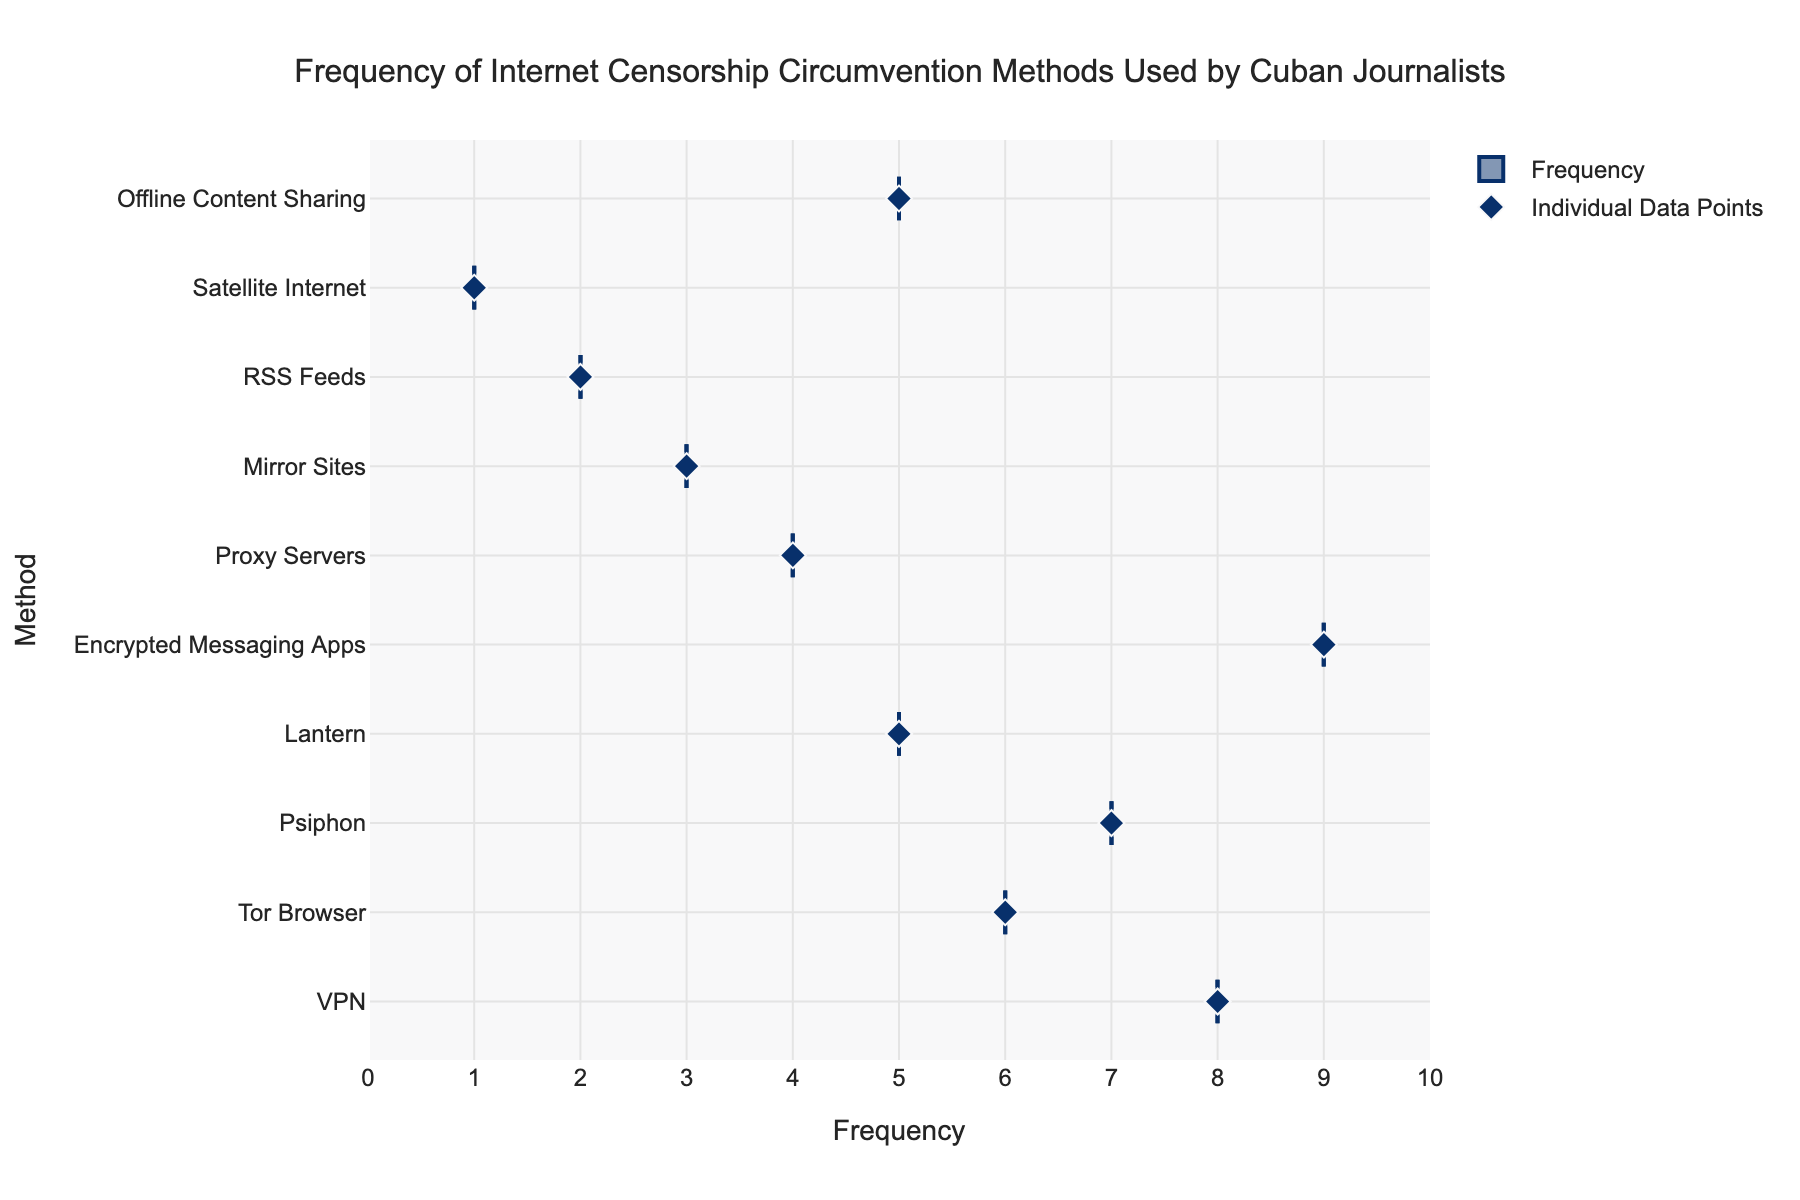What is the title of the plot? The title of the plot is located at the top of the figure and is usually the largest text element, centered above the plot area.
Answer: Frequency of Internet Censorship Circumvention Methods Used by Cuban Journalists What is the range of the x-axis? The x-axis range is indicated by the start and end values displayed along the x-axis line at the bottom of the plot.
Answer: 0 to 10 Which circumvention method is used most frequently? Look for the method with the highest frequency value on the x-axis corresponding to the farthest right data point.
Answer: Encrypted Messaging Apps What is the least used circumvention method among Cuban journalists? Identify the method with the lowest frequency value on the x-axis corresponding to the farthest left data point.
Answer: Satellite Internet How many circumvention methods have a frequency greater than 5? Count the dots that have their x-axis value greater than 5.
Answer: 5 Which circumvention methods have exactly the same frequency? Examine the x-axis values to find methods that share the same frequency number.
Answer: Lantern and Offline Content Sharing What is the median frequency of all methods? Since there are 10 methods, the median is the average of the 5th and 6th values when sorted by frequency. Here, the 5th and 6th values are 5 (Lantern, Offline Content Sharing) and 6 (Tor Browser) respectively. So, the median is (5+6)/2.
Answer: 5.5 What is the average frequency of all observed circumvention methods? Sum all the frequency values and divide by the total number of methods (10). The sum is 8+6+7+5+9+4+3+2+1+5 = 50, and the average is 50/10.
Answer: 5 